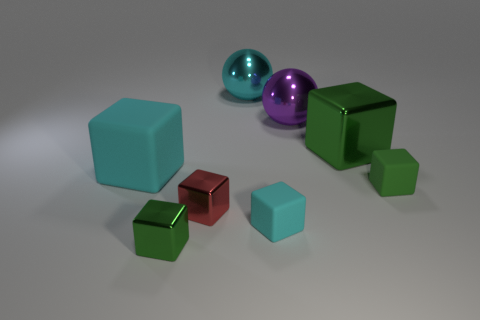Are there any purple balls behind the large cyan metallic sphere?
Your response must be concise. No. Is the size of the green shiny object in front of the green matte cube the same as the green shiny object right of the small cyan cube?
Keep it short and to the point. No. Are there any other shiny cubes that have the same size as the red metal block?
Your answer should be very brief. Yes. Does the large purple object right of the cyan shiny ball have the same shape as the big cyan rubber object?
Your response must be concise. No. What is the material of the green thing that is behind the large cyan matte thing?
Give a very brief answer. Metal. What shape is the green metal object that is in front of the cyan matte cube behind the red metallic block?
Your response must be concise. Cube. There is a tiny cyan thing; does it have the same shape as the small green object that is to the right of the big green metal cube?
Provide a short and direct response. Yes. There is a big metal object in front of the purple object; how many large cyan objects are in front of it?
Provide a short and direct response. 1. What is the material of the large cyan thing that is the same shape as the large green metallic thing?
Your response must be concise. Rubber. What number of purple things are big spheres or matte cubes?
Your answer should be very brief. 1. 